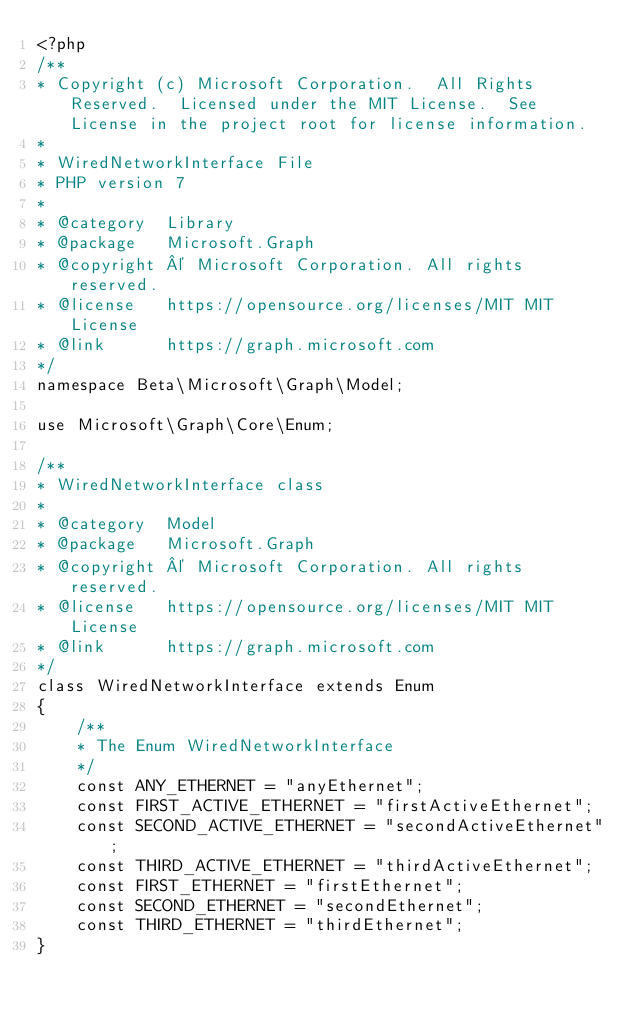<code> <loc_0><loc_0><loc_500><loc_500><_PHP_><?php
/**
* Copyright (c) Microsoft Corporation.  All Rights Reserved.  Licensed under the MIT License.  See License in the project root for license information.
* 
* WiredNetworkInterface File
* PHP version 7
*
* @category  Library
* @package   Microsoft.Graph
* @copyright © Microsoft Corporation. All rights reserved.
* @license   https://opensource.org/licenses/MIT MIT License
* @link      https://graph.microsoft.com
*/
namespace Beta\Microsoft\Graph\Model;

use Microsoft\Graph\Core\Enum;

/**
* WiredNetworkInterface class
*
* @category  Model
* @package   Microsoft.Graph
* @copyright © Microsoft Corporation. All rights reserved.
* @license   https://opensource.org/licenses/MIT MIT License
* @link      https://graph.microsoft.com
*/
class WiredNetworkInterface extends Enum
{
    /**
    * The Enum WiredNetworkInterface
    */
    const ANY_ETHERNET = "anyEthernet";
    const FIRST_ACTIVE_ETHERNET = "firstActiveEthernet";
    const SECOND_ACTIVE_ETHERNET = "secondActiveEthernet";
    const THIRD_ACTIVE_ETHERNET = "thirdActiveEthernet";
    const FIRST_ETHERNET = "firstEthernet";
    const SECOND_ETHERNET = "secondEthernet";
    const THIRD_ETHERNET = "thirdEthernet";
}</code> 